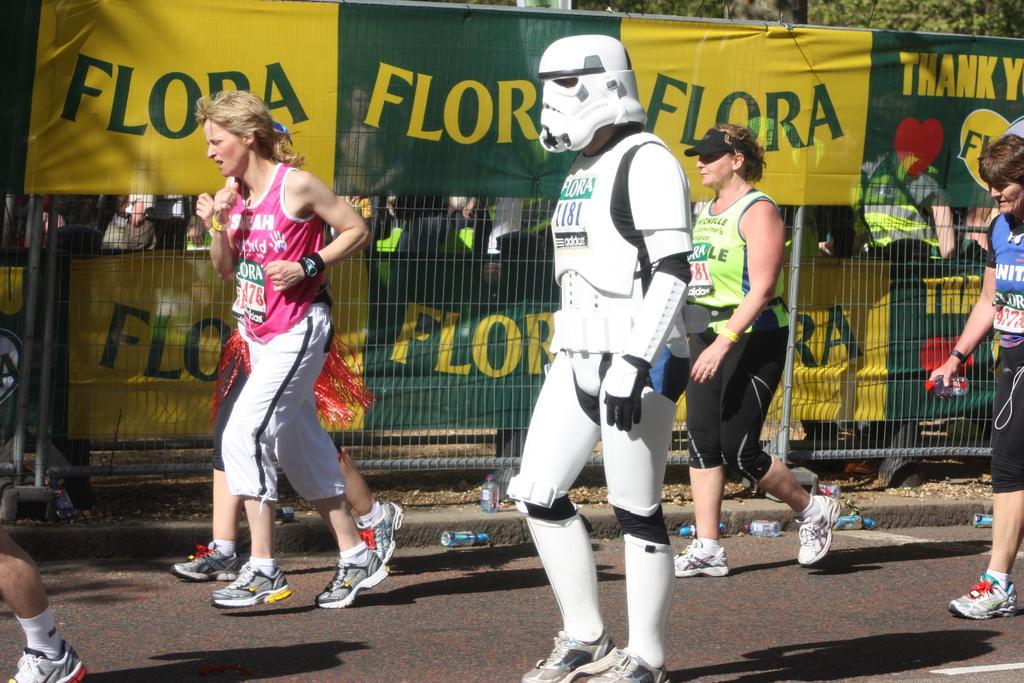Can you describe this image briefly? In this picture I can see there are few people jogging and in the backdrop there is a fence, banners and trees. 